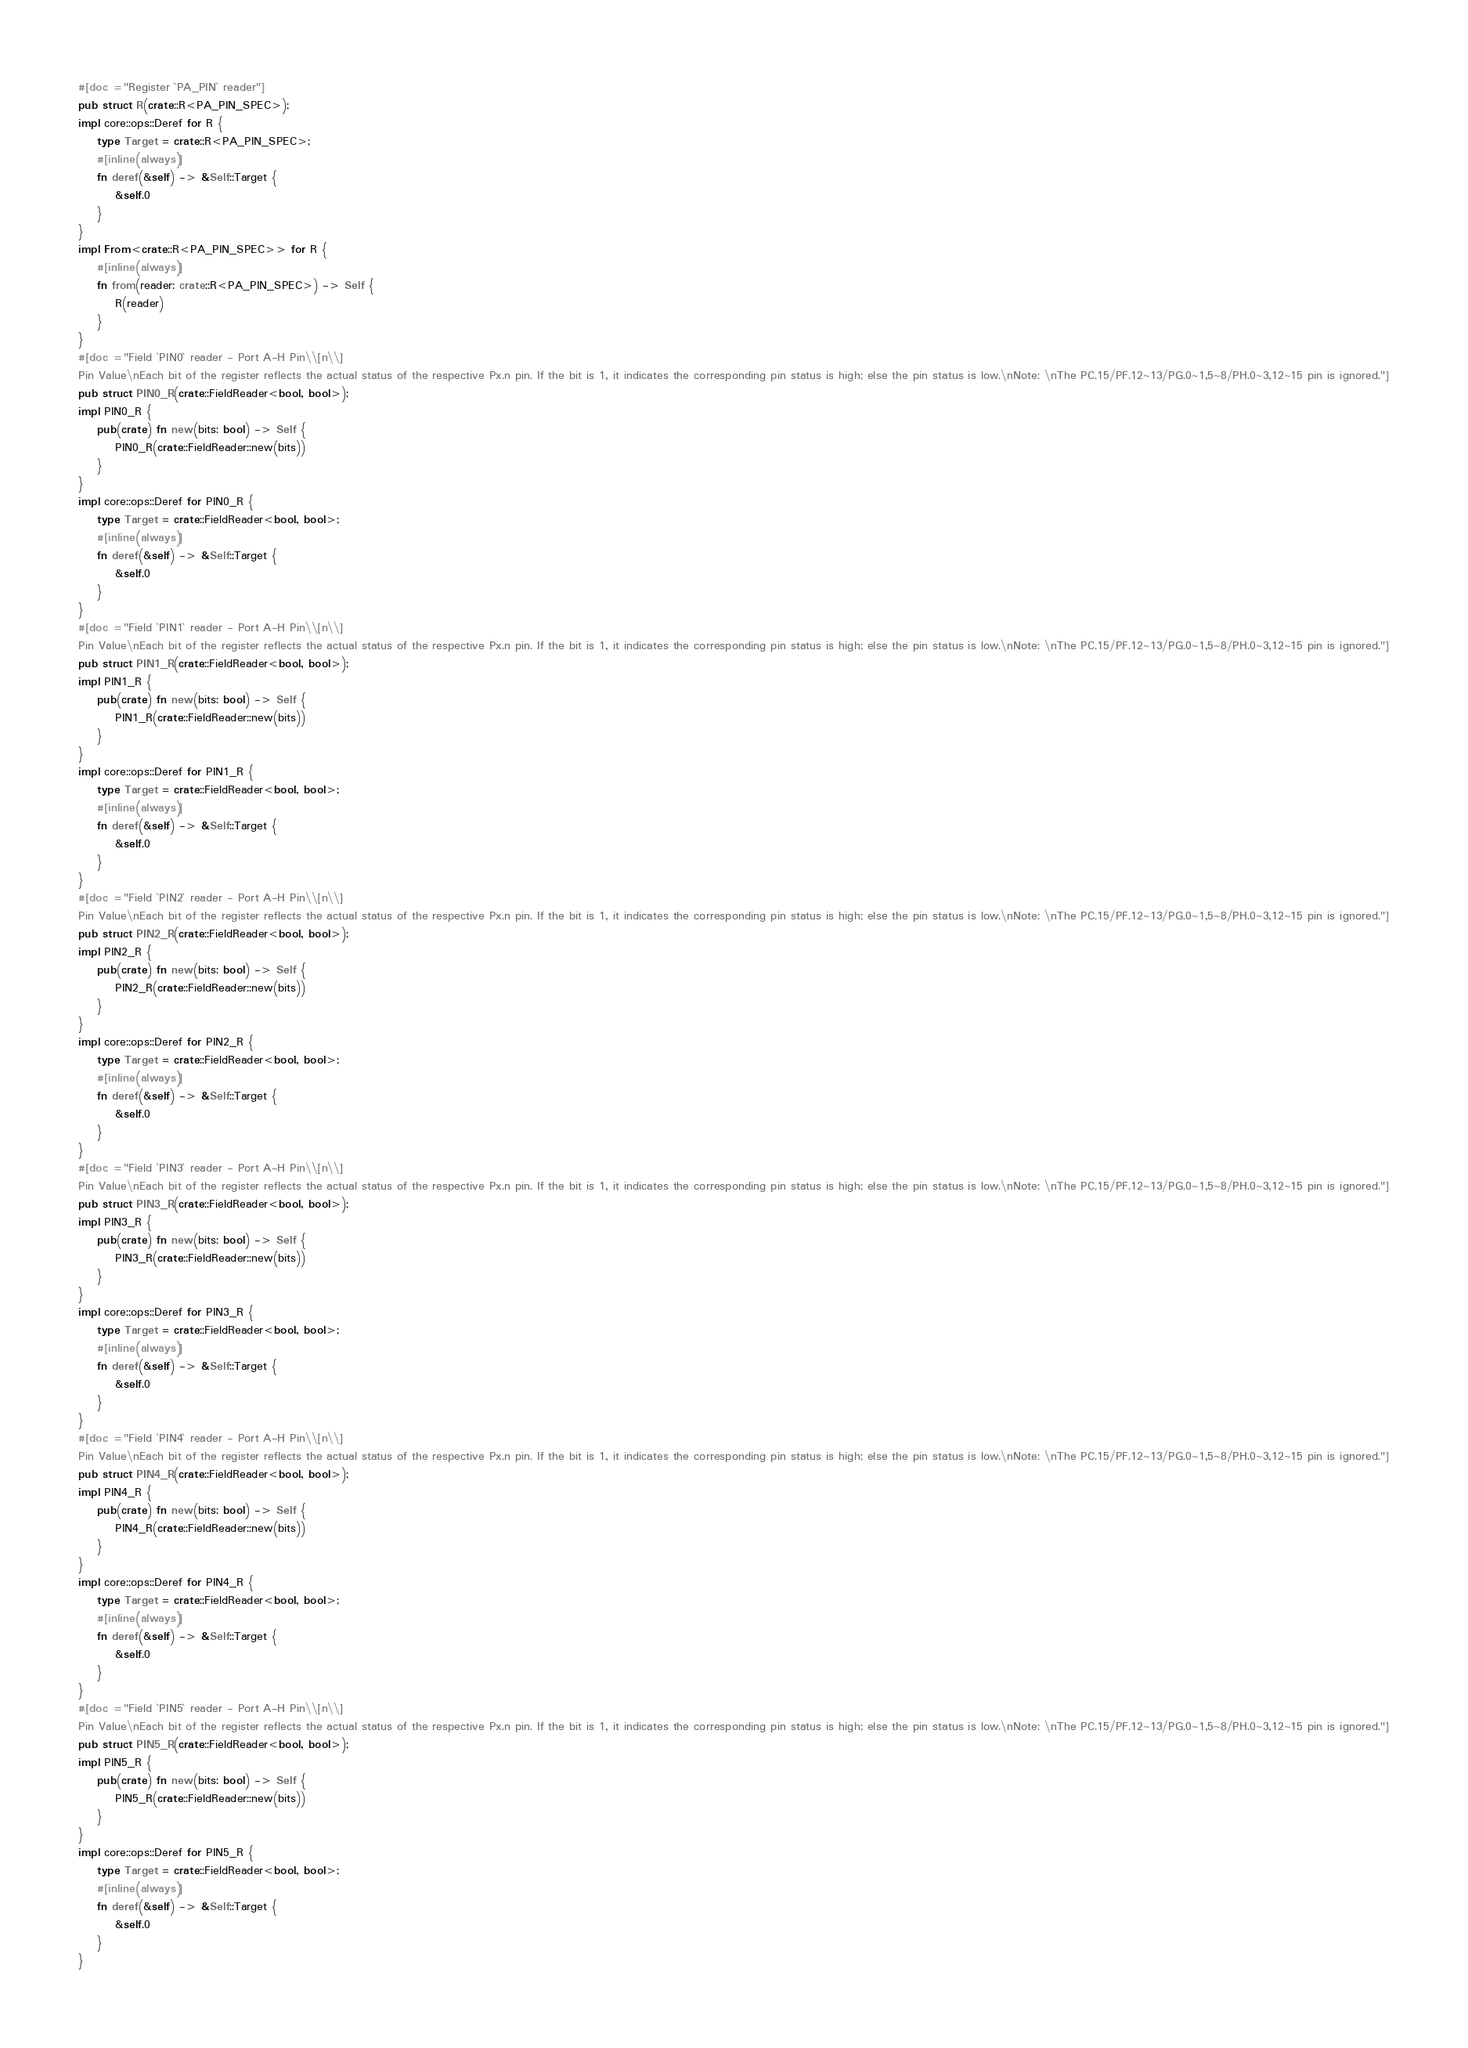Convert code to text. <code><loc_0><loc_0><loc_500><loc_500><_Rust_>#[doc = "Register `PA_PIN` reader"]
pub struct R(crate::R<PA_PIN_SPEC>);
impl core::ops::Deref for R {
    type Target = crate::R<PA_PIN_SPEC>;
    #[inline(always)]
    fn deref(&self) -> &Self::Target {
        &self.0
    }
}
impl From<crate::R<PA_PIN_SPEC>> for R {
    #[inline(always)]
    fn from(reader: crate::R<PA_PIN_SPEC>) -> Self {
        R(reader)
    }
}
#[doc = "Field `PIN0` reader - Port A-H Pin\\[n\\]
Pin Value\nEach bit of the register reflects the actual status of the respective Px.n pin. If the bit is 1, it indicates the corresponding pin status is high; else the pin status is low.\nNote: \nThe PC.15/PF.12~13/PG.0~1,5~8/PH.0~3,12~15 pin is ignored."]
pub struct PIN0_R(crate::FieldReader<bool, bool>);
impl PIN0_R {
    pub(crate) fn new(bits: bool) -> Self {
        PIN0_R(crate::FieldReader::new(bits))
    }
}
impl core::ops::Deref for PIN0_R {
    type Target = crate::FieldReader<bool, bool>;
    #[inline(always)]
    fn deref(&self) -> &Self::Target {
        &self.0
    }
}
#[doc = "Field `PIN1` reader - Port A-H Pin\\[n\\]
Pin Value\nEach bit of the register reflects the actual status of the respective Px.n pin. If the bit is 1, it indicates the corresponding pin status is high; else the pin status is low.\nNote: \nThe PC.15/PF.12~13/PG.0~1,5~8/PH.0~3,12~15 pin is ignored."]
pub struct PIN1_R(crate::FieldReader<bool, bool>);
impl PIN1_R {
    pub(crate) fn new(bits: bool) -> Self {
        PIN1_R(crate::FieldReader::new(bits))
    }
}
impl core::ops::Deref for PIN1_R {
    type Target = crate::FieldReader<bool, bool>;
    #[inline(always)]
    fn deref(&self) -> &Self::Target {
        &self.0
    }
}
#[doc = "Field `PIN2` reader - Port A-H Pin\\[n\\]
Pin Value\nEach bit of the register reflects the actual status of the respective Px.n pin. If the bit is 1, it indicates the corresponding pin status is high; else the pin status is low.\nNote: \nThe PC.15/PF.12~13/PG.0~1,5~8/PH.0~3,12~15 pin is ignored."]
pub struct PIN2_R(crate::FieldReader<bool, bool>);
impl PIN2_R {
    pub(crate) fn new(bits: bool) -> Self {
        PIN2_R(crate::FieldReader::new(bits))
    }
}
impl core::ops::Deref for PIN2_R {
    type Target = crate::FieldReader<bool, bool>;
    #[inline(always)]
    fn deref(&self) -> &Self::Target {
        &self.0
    }
}
#[doc = "Field `PIN3` reader - Port A-H Pin\\[n\\]
Pin Value\nEach bit of the register reflects the actual status of the respective Px.n pin. If the bit is 1, it indicates the corresponding pin status is high; else the pin status is low.\nNote: \nThe PC.15/PF.12~13/PG.0~1,5~8/PH.0~3,12~15 pin is ignored."]
pub struct PIN3_R(crate::FieldReader<bool, bool>);
impl PIN3_R {
    pub(crate) fn new(bits: bool) -> Self {
        PIN3_R(crate::FieldReader::new(bits))
    }
}
impl core::ops::Deref for PIN3_R {
    type Target = crate::FieldReader<bool, bool>;
    #[inline(always)]
    fn deref(&self) -> &Self::Target {
        &self.0
    }
}
#[doc = "Field `PIN4` reader - Port A-H Pin\\[n\\]
Pin Value\nEach bit of the register reflects the actual status of the respective Px.n pin. If the bit is 1, it indicates the corresponding pin status is high; else the pin status is low.\nNote: \nThe PC.15/PF.12~13/PG.0~1,5~8/PH.0~3,12~15 pin is ignored."]
pub struct PIN4_R(crate::FieldReader<bool, bool>);
impl PIN4_R {
    pub(crate) fn new(bits: bool) -> Self {
        PIN4_R(crate::FieldReader::new(bits))
    }
}
impl core::ops::Deref for PIN4_R {
    type Target = crate::FieldReader<bool, bool>;
    #[inline(always)]
    fn deref(&self) -> &Self::Target {
        &self.0
    }
}
#[doc = "Field `PIN5` reader - Port A-H Pin\\[n\\]
Pin Value\nEach bit of the register reflects the actual status of the respective Px.n pin. If the bit is 1, it indicates the corresponding pin status is high; else the pin status is low.\nNote: \nThe PC.15/PF.12~13/PG.0~1,5~8/PH.0~3,12~15 pin is ignored."]
pub struct PIN5_R(crate::FieldReader<bool, bool>);
impl PIN5_R {
    pub(crate) fn new(bits: bool) -> Self {
        PIN5_R(crate::FieldReader::new(bits))
    }
}
impl core::ops::Deref for PIN5_R {
    type Target = crate::FieldReader<bool, bool>;
    #[inline(always)]
    fn deref(&self) -> &Self::Target {
        &self.0
    }
}</code> 